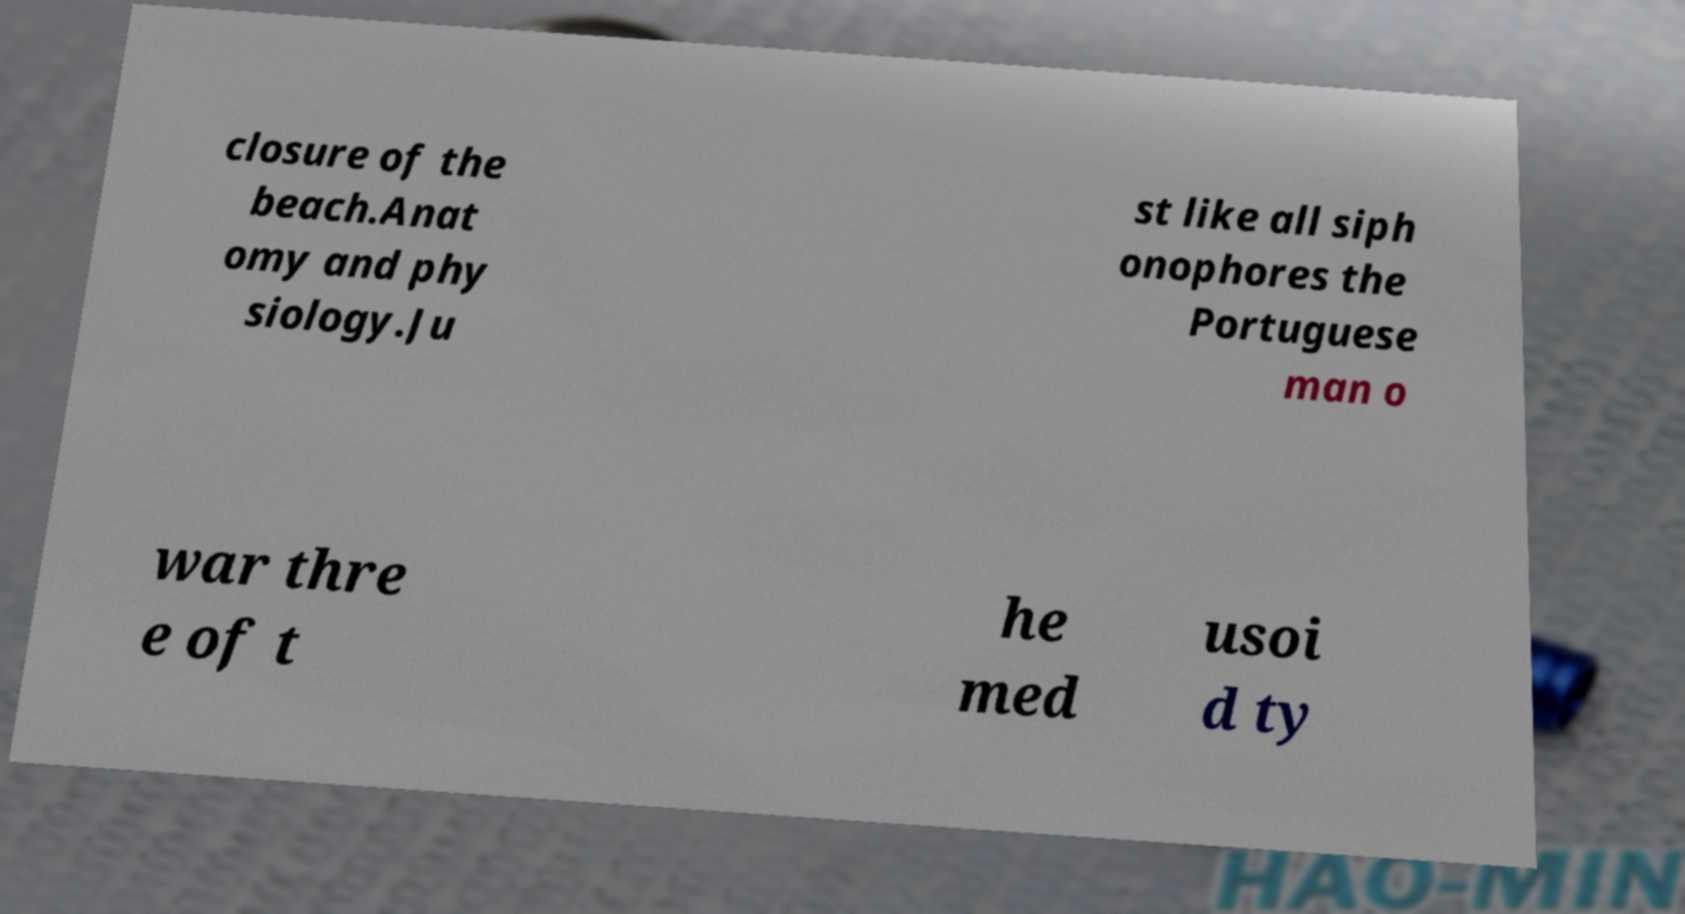Could you assist in decoding the text presented in this image and type it out clearly? closure of the beach.Anat omy and phy siology.Ju st like all siph onophores the Portuguese man o war thre e of t he med usoi d ty 